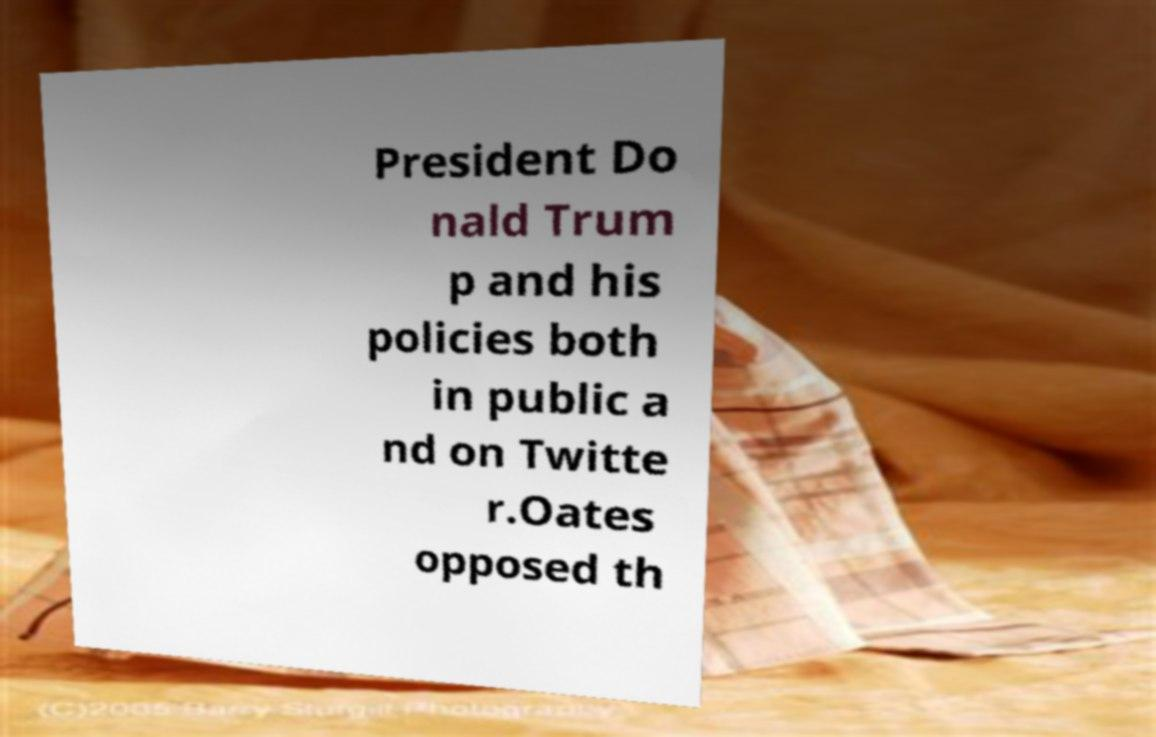What messages or text are displayed in this image? I need them in a readable, typed format. President Do nald Trum p and his policies both in public a nd on Twitte r.Oates opposed th 